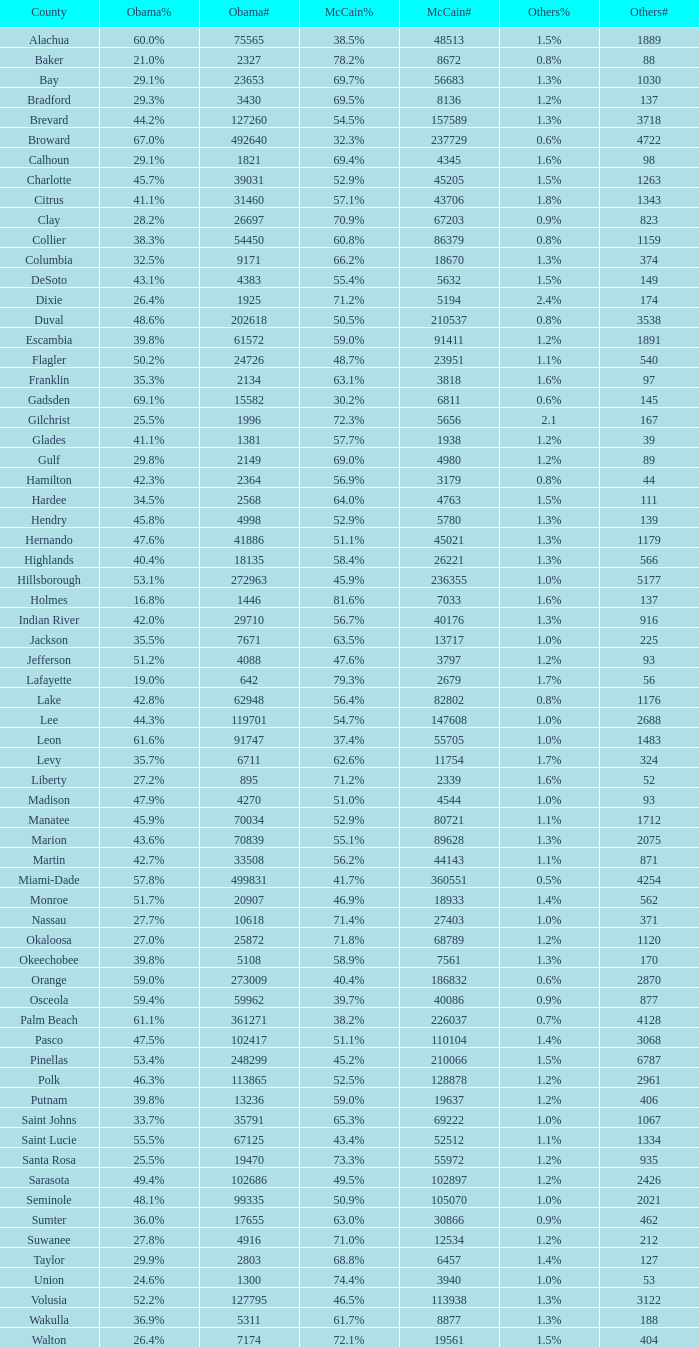What was the number of others votes in Columbia county? 374.0. 